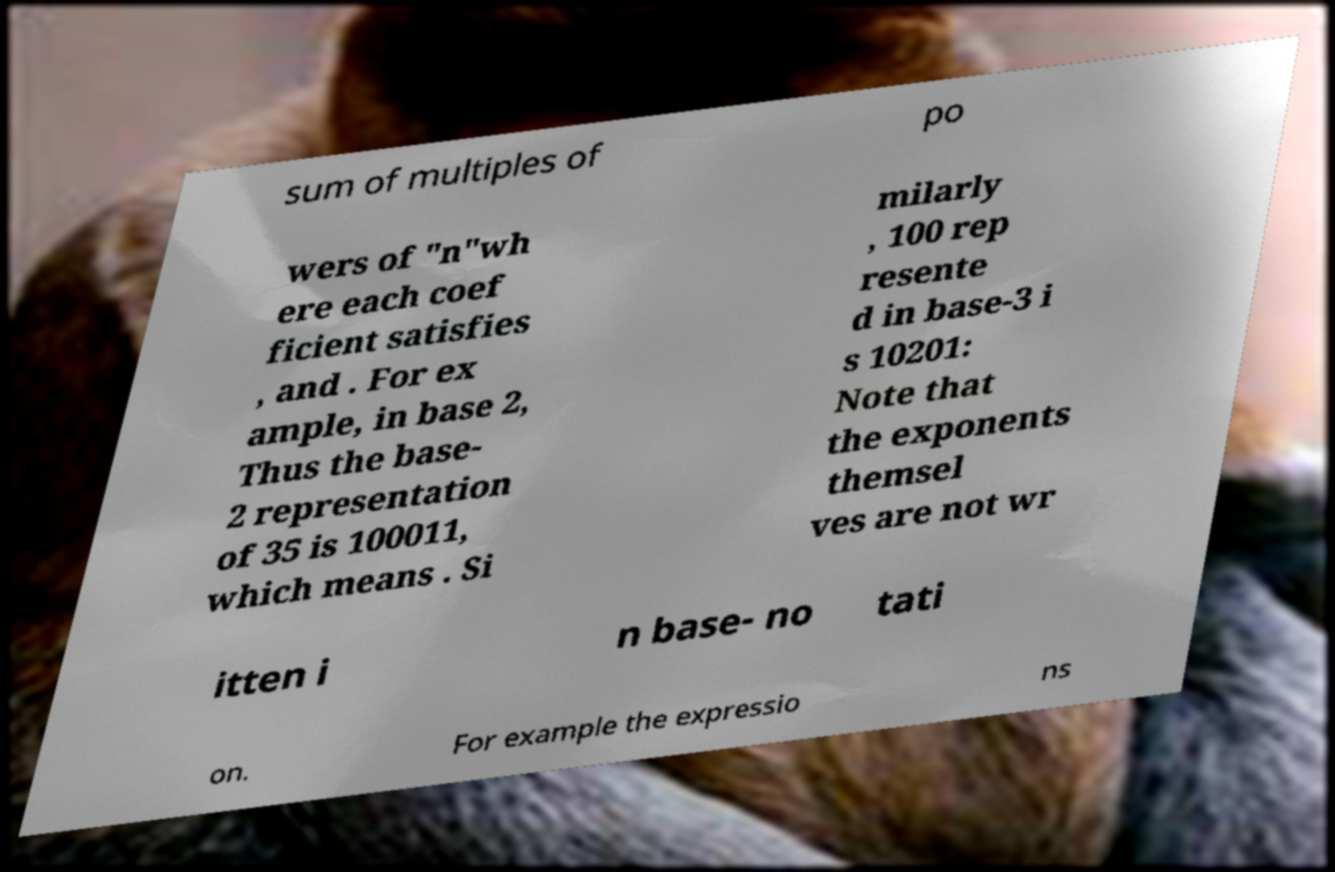Can you accurately transcribe the text from the provided image for me? sum of multiples of po wers of "n"wh ere each coef ficient satisfies , and . For ex ample, in base 2, Thus the base- 2 representation of 35 is 100011, which means . Si milarly , 100 rep resente d in base-3 i s 10201: Note that the exponents themsel ves are not wr itten i n base- no tati on. For example the expressio ns 